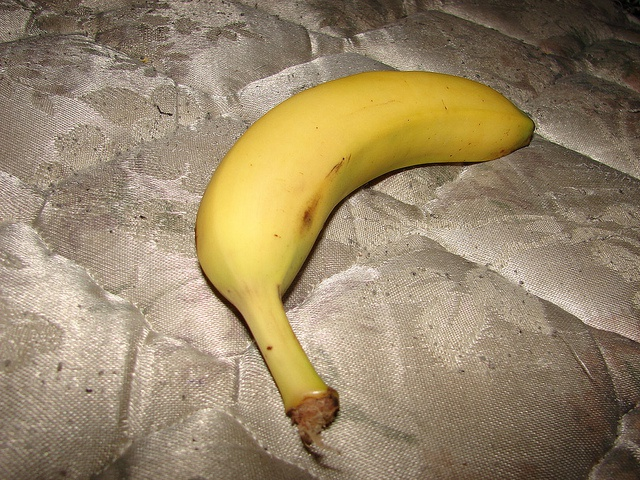Describe the objects in this image and their specific colors. I can see bed in tan and gray tones and banana in black, gold, olive, and orange tones in this image. 